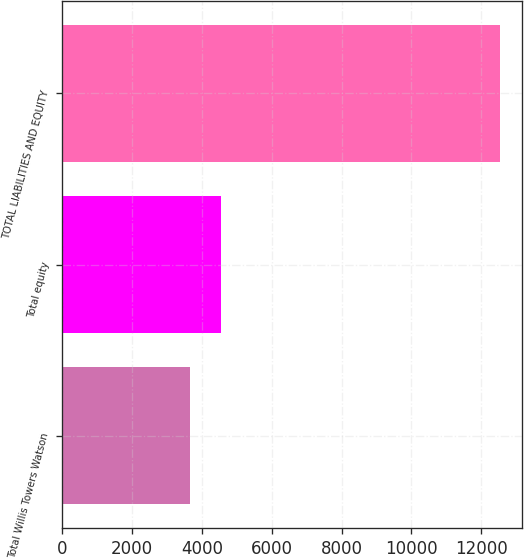Convert chart. <chart><loc_0><loc_0><loc_500><loc_500><bar_chart><fcel>Total Willis Towers Watson<fcel>Total equity<fcel>TOTAL LIABILITIES AND EQUITY<nl><fcel>3653<fcel>4541.5<fcel>12538<nl></chart> 